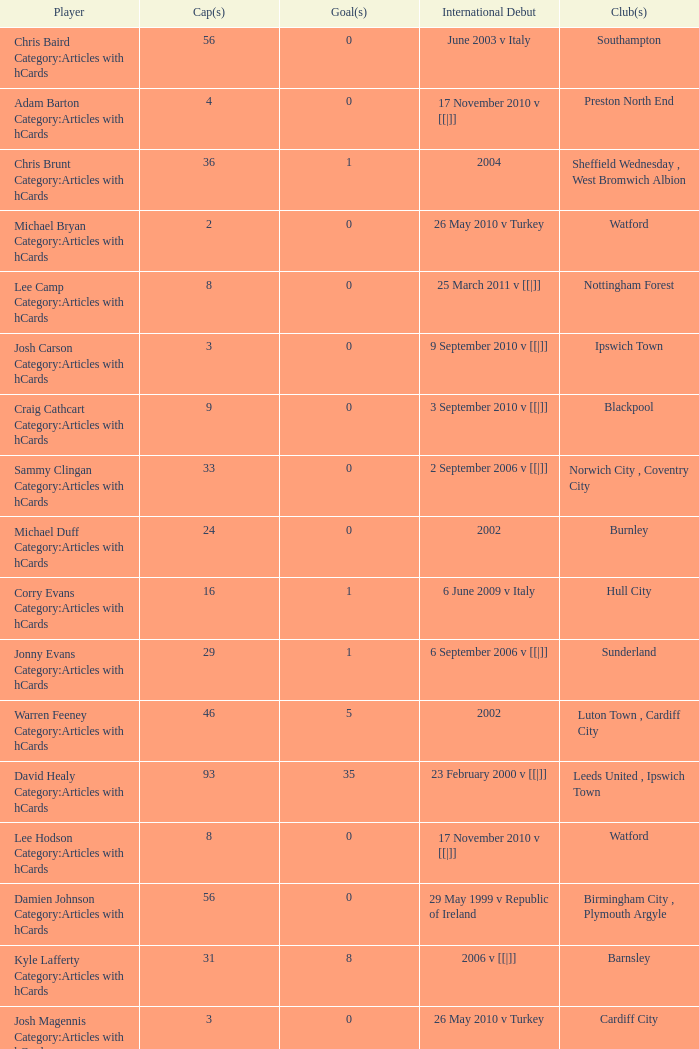How many caps figures for the Doncaster Rovers? 1.0. 